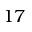Convert formula to latex. <formula><loc_0><loc_0><loc_500><loc_500>1 7</formula> 